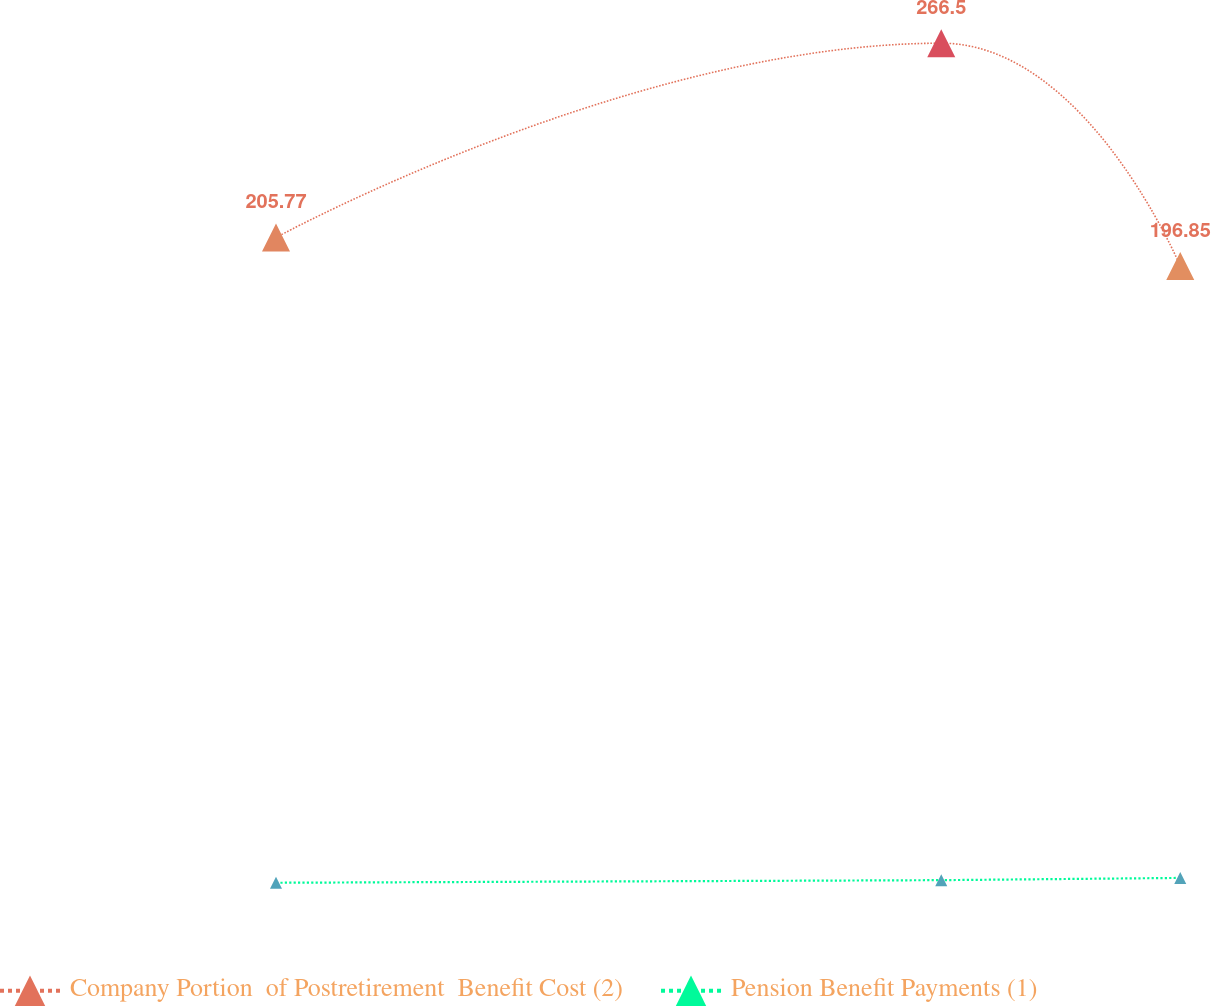Convert chart. <chart><loc_0><loc_0><loc_500><loc_500><line_chart><ecel><fcel>Company Portion  of Postretirement  Benefit Cost (2)<fcel>Pension Benefit Payments (1)<nl><fcel>1625.85<fcel>205.77<fcel>4.14<nl><fcel>2058.48<fcel>266.5<fcel>4.95<nl><fcel>2213.9<fcel>196.85<fcel>5.65<nl><fcel>2380.43<fcel>233.9<fcel>4.29<nl><fcel>2458.27<fcel>225.47<fcel>4.72<nl></chart> 